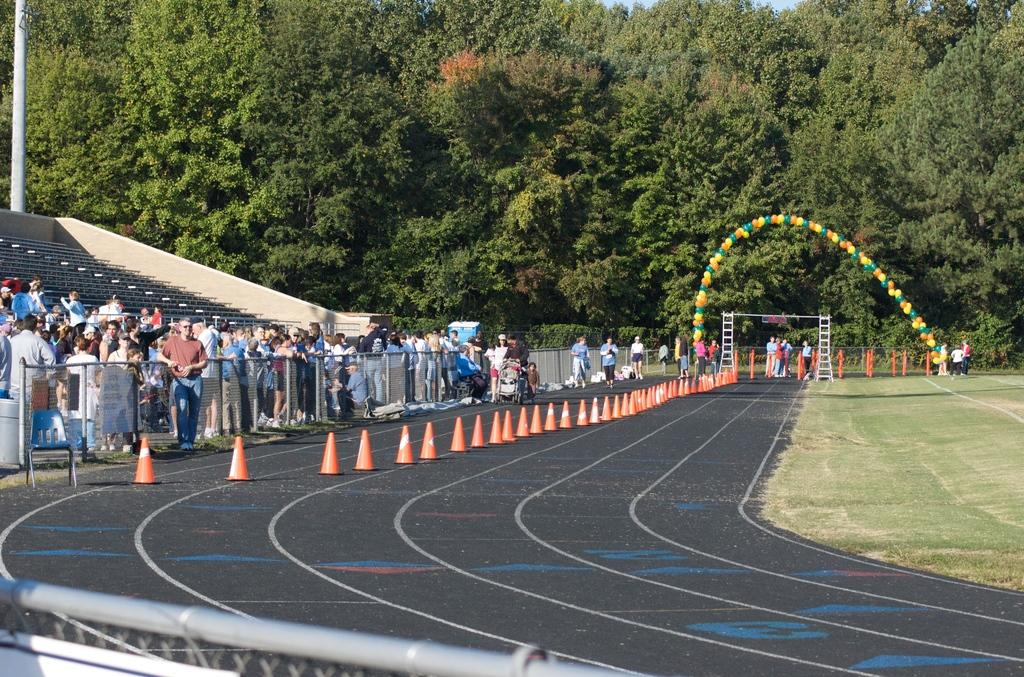What is the main subject of the image? The main subject of the image is a group of people standing. What objects are present in the image besides the people? Chairs, iron rods, cone barricades, balloons, and trees are visible in the image. What might the people be using the chairs for? The chairs could be used for sitting or standing on. What is the purpose of the cone barricades in the image? The cone barricades are likely used to direct traffic or indicate a construction area. What thought is the boy expressing in the image? There is no boy present in the image, and therefore no thought can be attributed to a boy. 